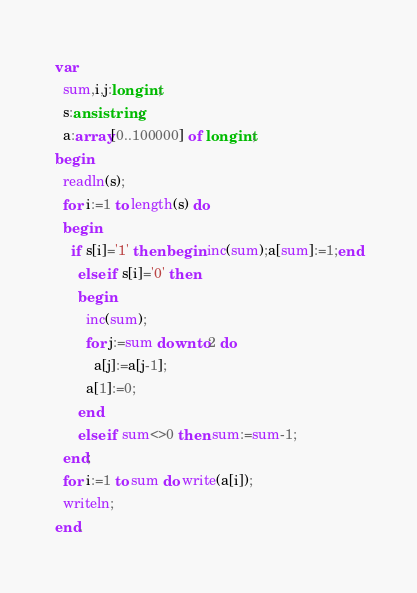<code> <loc_0><loc_0><loc_500><loc_500><_Pascal_>var
  sum,i,j:longint;
  s:ansistring;
  a:array[0..100000] of longint;
begin
  readln(s);
  for i:=1 to length(s) do
  begin
    if s[i]='1' then begin inc(sum);a[sum]:=1;end
      else if s[i]='0' then
      begin
        inc(sum);
        for j:=sum downto 2 do
          a[j]:=a[j-1];
        a[1]:=0;
      end
      else if sum<>0 then sum:=sum-1;
  end;
  for i:=1 to sum do write(a[i]);
  writeln;
end.</code> 